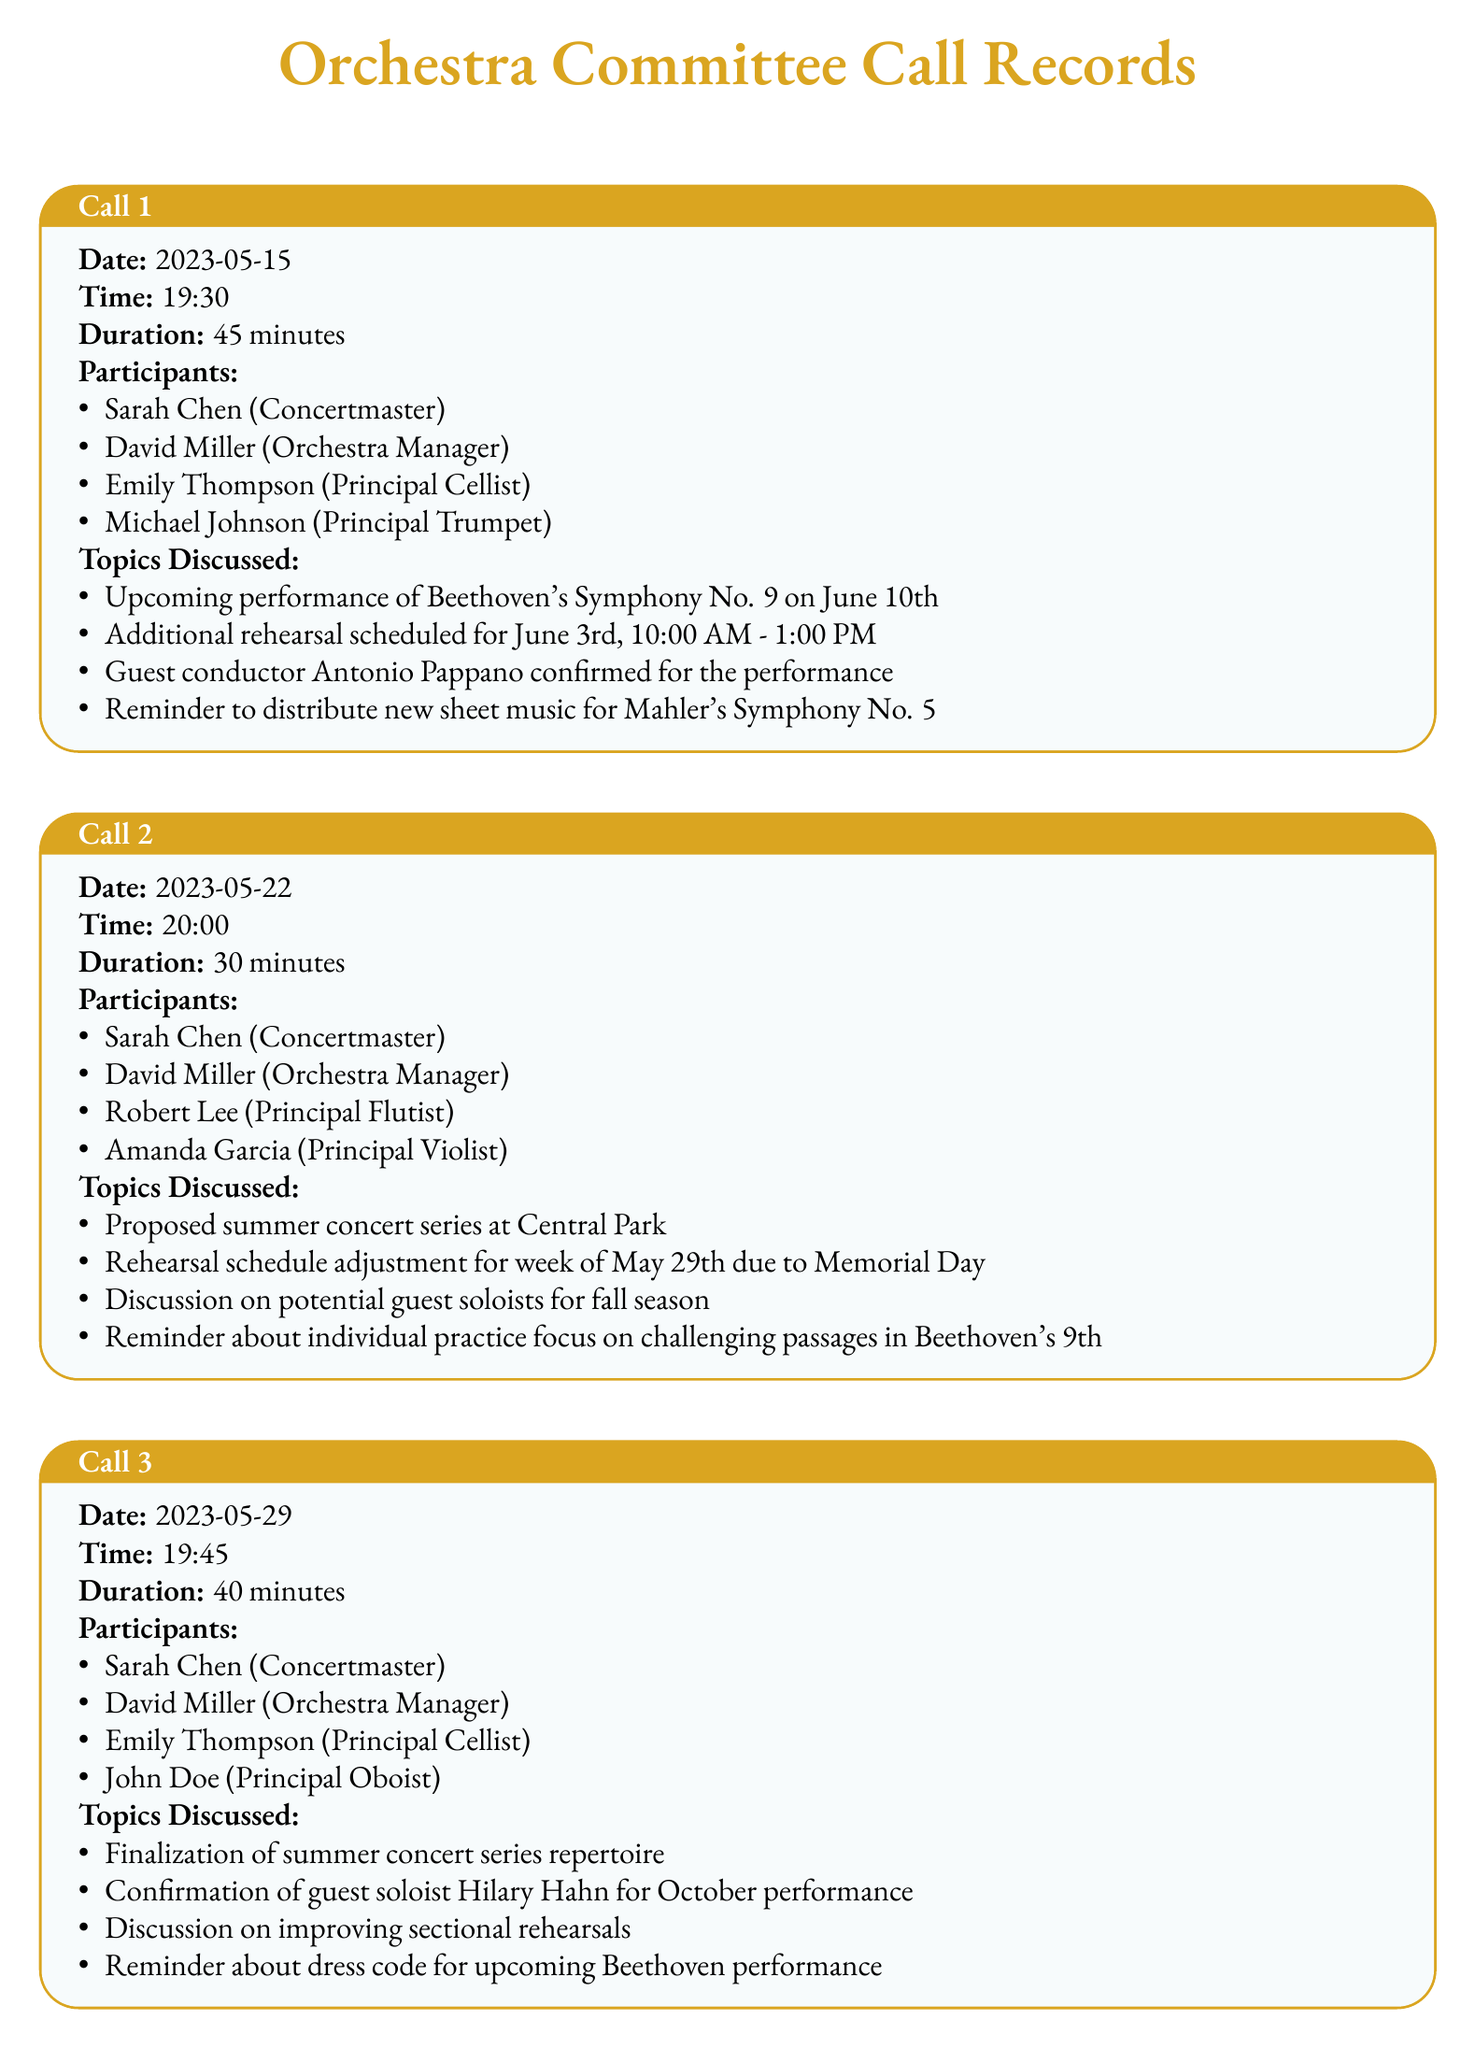what is the date of the first call? The date of the first call is specified in the records, which is 2023-05-15.
Answer: 2023-05-15 who was the guest conductor confirmed for the performance? The document mentions a guest conductor who was confirmed for the upcoming performance, which is Antonio Pappano.
Answer: Antonio Pappano how long did the second call last? The duration of the second call is recorded in the document, which is 30 minutes.
Answer: 30 minutes name one topic discussed in the third call. The document includes several topics discussed, one of which is the finalization of summer concert series repertoire.
Answer: finalization of summer concert series repertoire which principal musician is associated with the first call? The list of participants in the first call includes several principal musicians, such as Emily Thompson (Principal Cellist).
Answer: Emily Thompson (Principal Cellist) how many calls were recorded in total? The document shows that there were three calls listed, indicating the total number of calls recorded.
Answer: 3 what is the rehearsal schedule adjustment for the second call? The second call details a specific adjustment to the rehearsal schedule due to Memorial Day.
Answer: adjustment for week of May 29th due to Memorial Day who is the confirmed guest soloist for the October performance? The document explicitly states that Hilary Hahn is the confirmed guest soloist for the October performance.
Answer: Hilary Hahn 